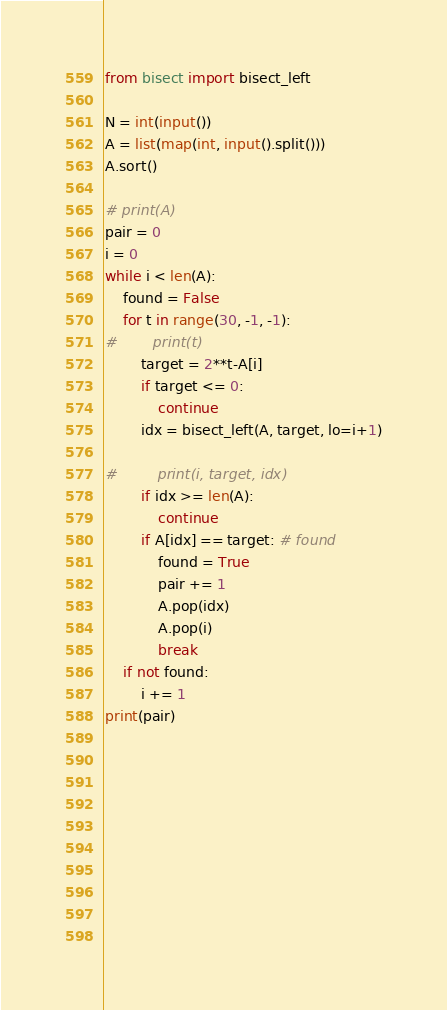<code> <loc_0><loc_0><loc_500><loc_500><_Python_>from bisect import bisect_left

N = int(input())
A = list(map(int, input().split()))
A.sort()

# print(A)
pair = 0
i = 0
while i < len(A):
    found = False
    for t in range(30, -1, -1):
#        print(t)
        target = 2**t-A[i]
        if target <= 0:
            continue
        idx = bisect_left(A, target, lo=i+1)
        
#         print(i, target, idx)
        if idx >= len(A):
            continue
        if A[idx] == target: # found
            found = True
            pair += 1
            A.pop(idx)
            A.pop(i)
            break
    if not found:
        i += 1
print(pair)

    
            
        
        
        
        
        
    
    
</code> 